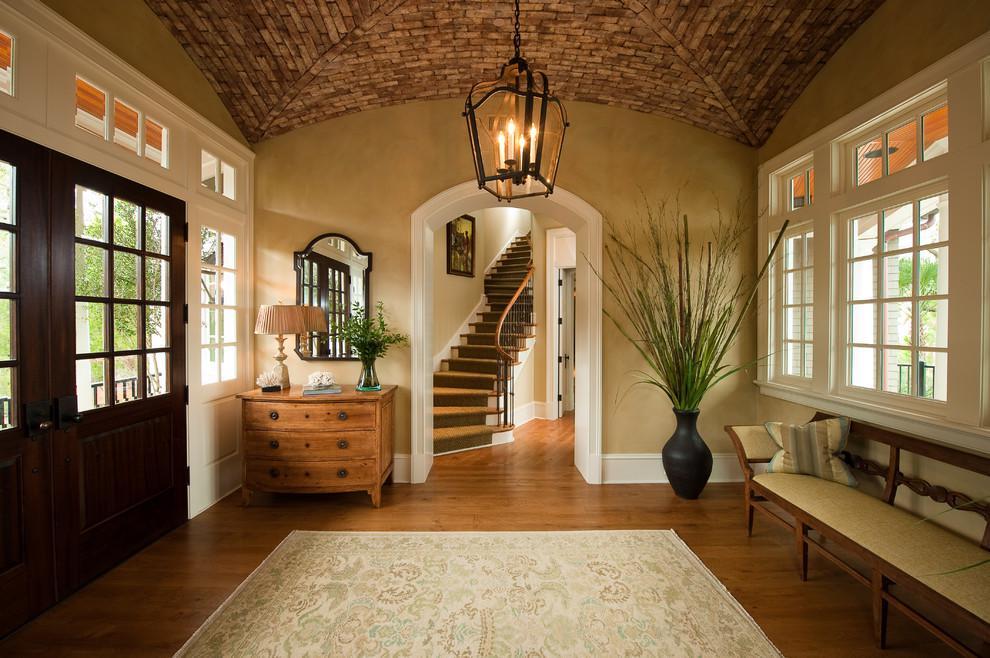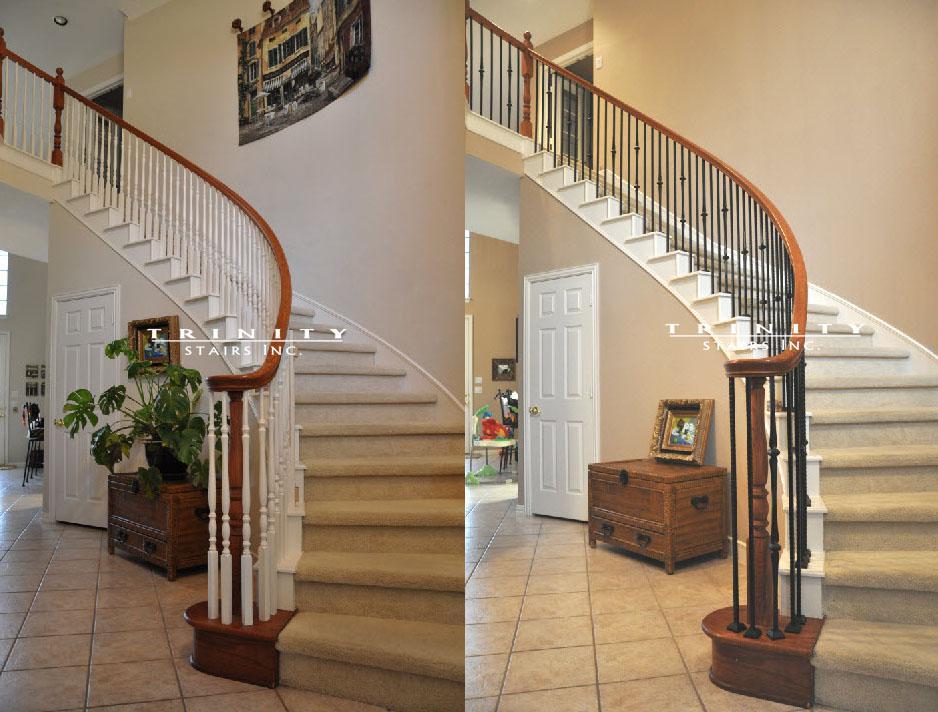The first image is the image on the left, the second image is the image on the right. For the images shown, is this caption "One image contains two curved stairways with carpeted steps, white base boards, and brown handrails and balusters, and at least one of the stairways has white spindles." true? Answer yes or no. Yes. The first image is the image on the left, the second image is the image on the right. Given the left and right images, does the statement "In at least one image there is a flight of stair facing left with a railing that has thin rods spaced out." hold true? Answer yes or no. No. 